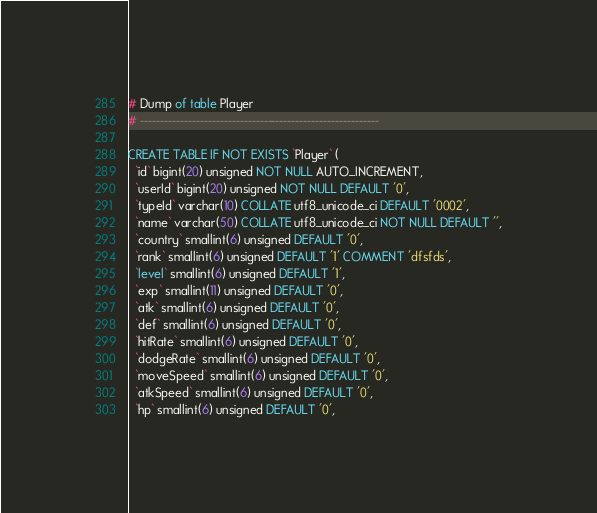Convert code to text. <code><loc_0><loc_0><loc_500><loc_500><_SQL_>
# Dump of table Player
# ------------------------------------------------------------

CREATE TABLE IF NOT EXISTS `Player` (
  `id` bigint(20) unsigned NOT NULL AUTO_INCREMENT,
  `userId` bigint(20) unsigned NOT NULL DEFAULT '0',
  `typeId` varchar(10) COLLATE utf8_unicode_ci DEFAULT '0002',
  `name` varchar(50) COLLATE utf8_unicode_ci NOT NULL DEFAULT '',
  `country` smallint(6) unsigned DEFAULT '0',
  `rank` smallint(6) unsigned DEFAULT '1' COMMENT 'dfsfds',
  `level` smallint(6) unsigned DEFAULT '1',
  `exp` smallint(11) unsigned DEFAULT '0',
  `atk` smallint(6) unsigned DEFAULT '0',
  `def` smallint(6) unsigned DEFAULT '0',
  `hitRate` smallint(6) unsigned DEFAULT '0',
  `dodgeRate` smallint(6) unsigned DEFAULT '0',
  `moveSpeed` smallint(6) unsigned DEFAULT '0',
  `atkSpeed` smallint(6) unsigned DEFAULT '0',
  `hp` smallint(6) unsigned DEFAULT '0',</code> 